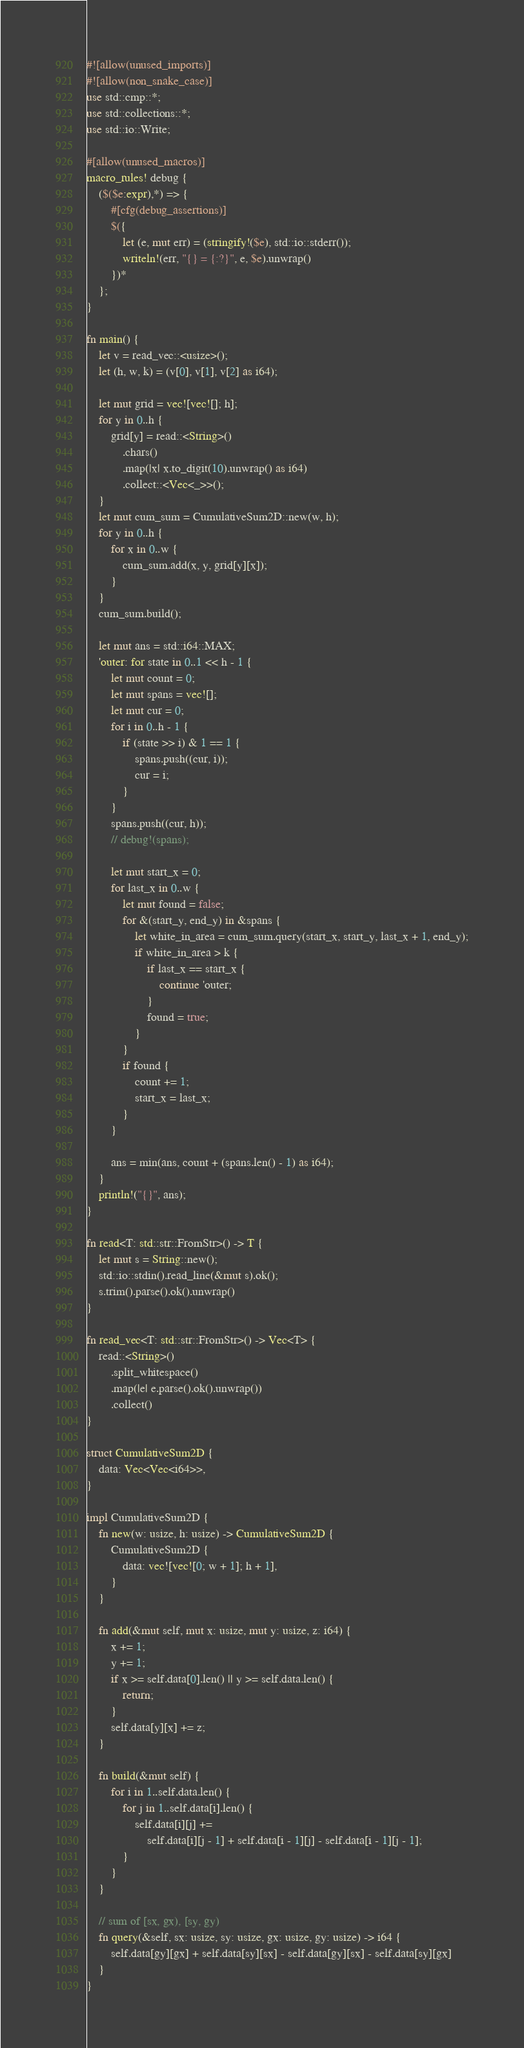<code> <loc_0><loc_0><loc_500><loc_500><_Rust_>#![allow(unused_imports)]
#![allow(non_snake_case)]
use std::cmp::*;
use std::collections::*;
use std::io::Write;

#[allow(unused_macros)]
macro_rules! debug {
    ($($e:expr),*) => {
        #[cfg(debug_assertions)]
        $({
            let (e, mut err) = (stringify!($e), std::io::stderr());
            writeln!(err, "{} = {:?}", e, $e).unwrap()
        })*
    };
}

fn main() {
    let v = read_vec::<usize>();
    let (h, w, k) = (v[0], v[1], v[2] as i64);

    let mut grid = vec![vec![]; h];
    for y in 0..h {
        grid[y] = read::<String>()
            .chars()
            .map(|x| x.to_digit(10).unwrap() as i64)
            .collect::<Vec<_>>();
    }
    let mut cum_sum = CumulativeSum2D::new(w, h);
    for y in 0..h {
        for x in 0..w {
            cum_sum.add(x, y, grid[y][x]);
        }
    }
    cum_sum.build();

    let mut ans = std::i64::MAX;
    'outer: for state in 0..1 << h - 1 {
        let mut count = 0;
        let mut spans = vec![];
        let mut cur = 0;
        for i in 0..h - 1 {
            if (state >> i) & 1 == 1 {
                spans.push((cur, i));
                cur = i;
            }
        }
        spans.push((cur, h));
        // debug!(spans);

        let mut start_x = 0;
        for last_x in 0..w {
            let mut found = false;
            for &(start_y, end_y) in &spans {
                let white_in_area = cum_sum.query(start_x, start_y, last_x + 1, end_y);
                if white_in_area > k {
                    if last_x == start_x {
                        continue 'outer;
                    }
                    found = true;
                }
            }
            if found {
                count += 1;
                start_x = last_x;
            }
        }

        ans = min(ans, count + (spans.len() - 1) as i64);
    }
    println!("{}", ans);
}

fn read<T: std::str::FromStr>() -> T {
    let mut s = String::new();
    std::io::stdin().read_line(&mut s).ok();
    s.trim().parse().ok().unwrap()
}

fn read_vec<T: std::str::FromStr>() -> Vec<T> {
    read::<String>()
        .split_whitespace()
        .map(|e| e.parse().ok().unwrap())
        .collect()
}

struct CumulativeSum2D {
    data: Vec<Vec<i64>>,
}

impl CumulativeSum2D {
    fn new(w: usize, h: usize) -> CumulativeSum2D {
        CumulativeSum2D {
            data: vec![vec![0; w + 1]; h + 1],
        }
    }

    fn add(&mut self, mut x: usize, mut y: usize, z: i64) {
        x += 1;
        y += 1;
        if x >= self.data[0].len() || y >= self.data.len() {
            return;
        }
        self.data[y][x] += z;
    }

    fn build(&mut self) {
        for i in 1..self.data.len() {
            for j in 1..self.data[i].len() {
                self.data[i][j] +=
                    self.data[i][j - 1] + self.data[i - 1][j] - self.data[i - 1][j - 1];
            }
        }
    }

    // sum of [sx, gx), [sy, gy)
    fn query(&self, sx: usize, sy: usize, gx: usize, gy: usize) -> i64 {
        self.data[gy][gx] + self.data[sy][sx] - self.data[gy][sx] - self.data[sy][gx]
    }
}
</code> 